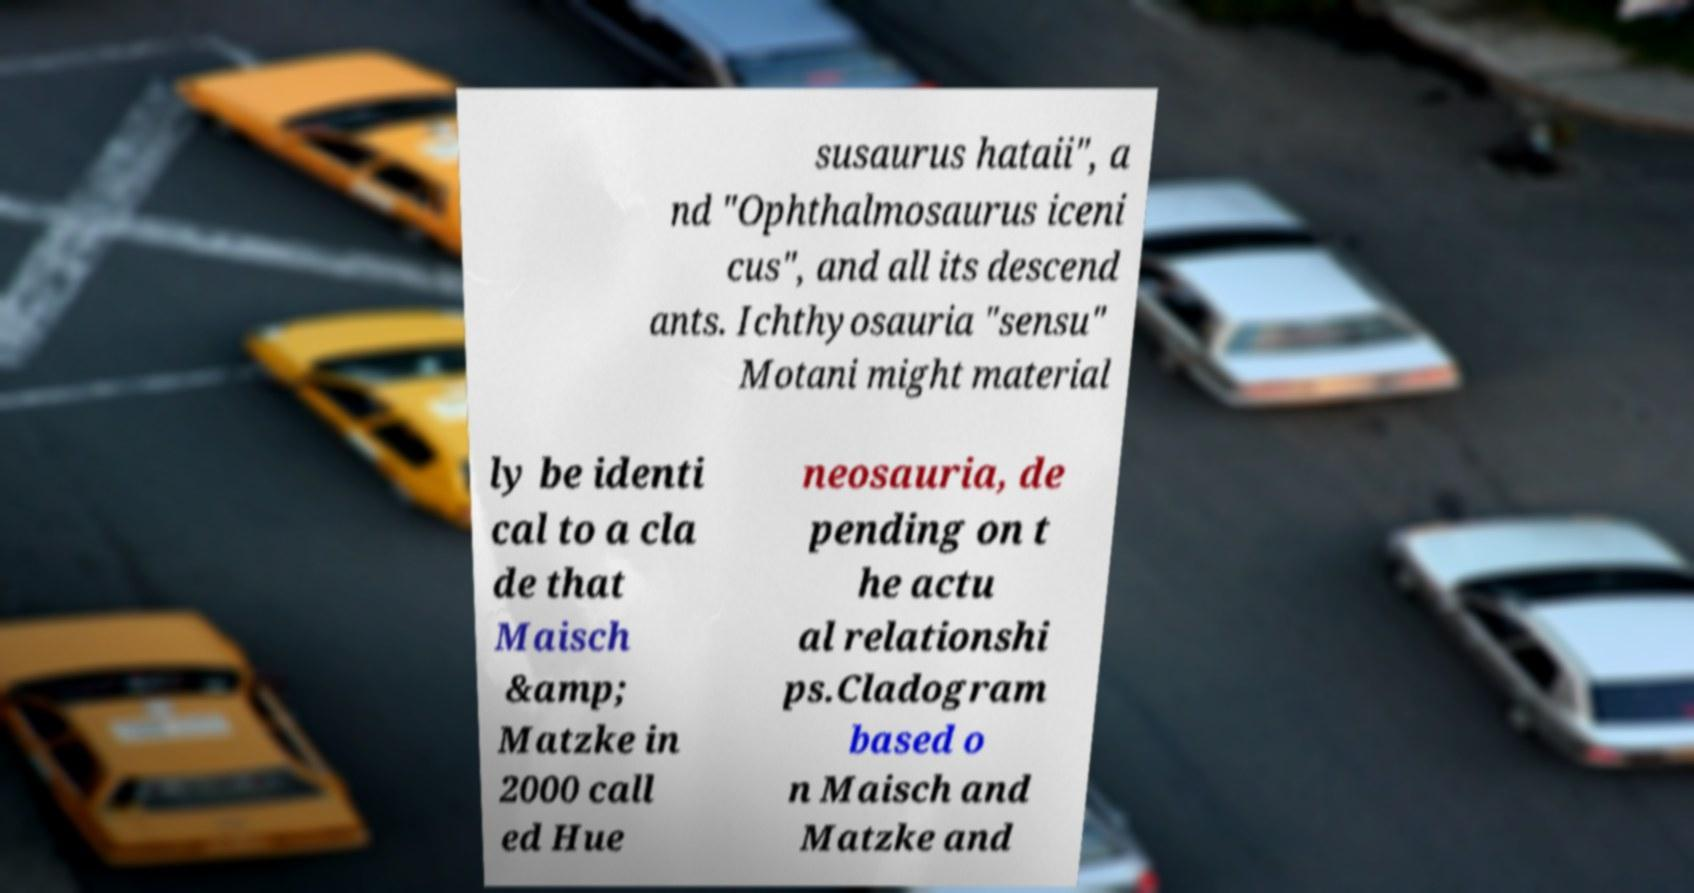Please identify and transcribe the text found in this image. susaurus hataii", a nd "Ophthalmosaurus iceni cus", and all its descend ants. Ichthyosauria "sensu" Motani might material ly be identi cal to a cla de that Maisch &amp; Matzke in 2000 call ed Hue neosauria, de pending on t he actu al relationshi ps.Cladogram based o n Maisch and Matzke and 